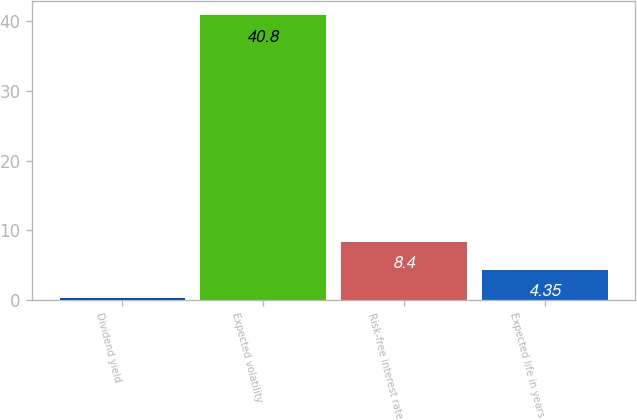Convert chart to OTSL. <chart><loc_0><loc_0><loc_500><loc_500><bar_chart><fcel>Dividend yield<fcel>Expected volatility<fcel>Risk-free interest rate<fcel>Expected life in years<nl><fcel>0.3<fcel>40.8<fcel>8.4<fcel>4.35<nl></chart> 